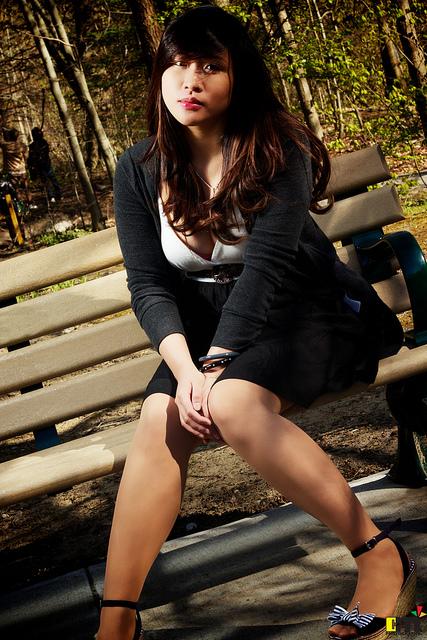Is the wearing stilettos?
Answer briefly. No. Does this woman have short hair?
Short answer required. No. Is he wearing sunglasses?
Be succinct. No. Is there a bow on this ladies shoes?
Answer briefly. Yes. 